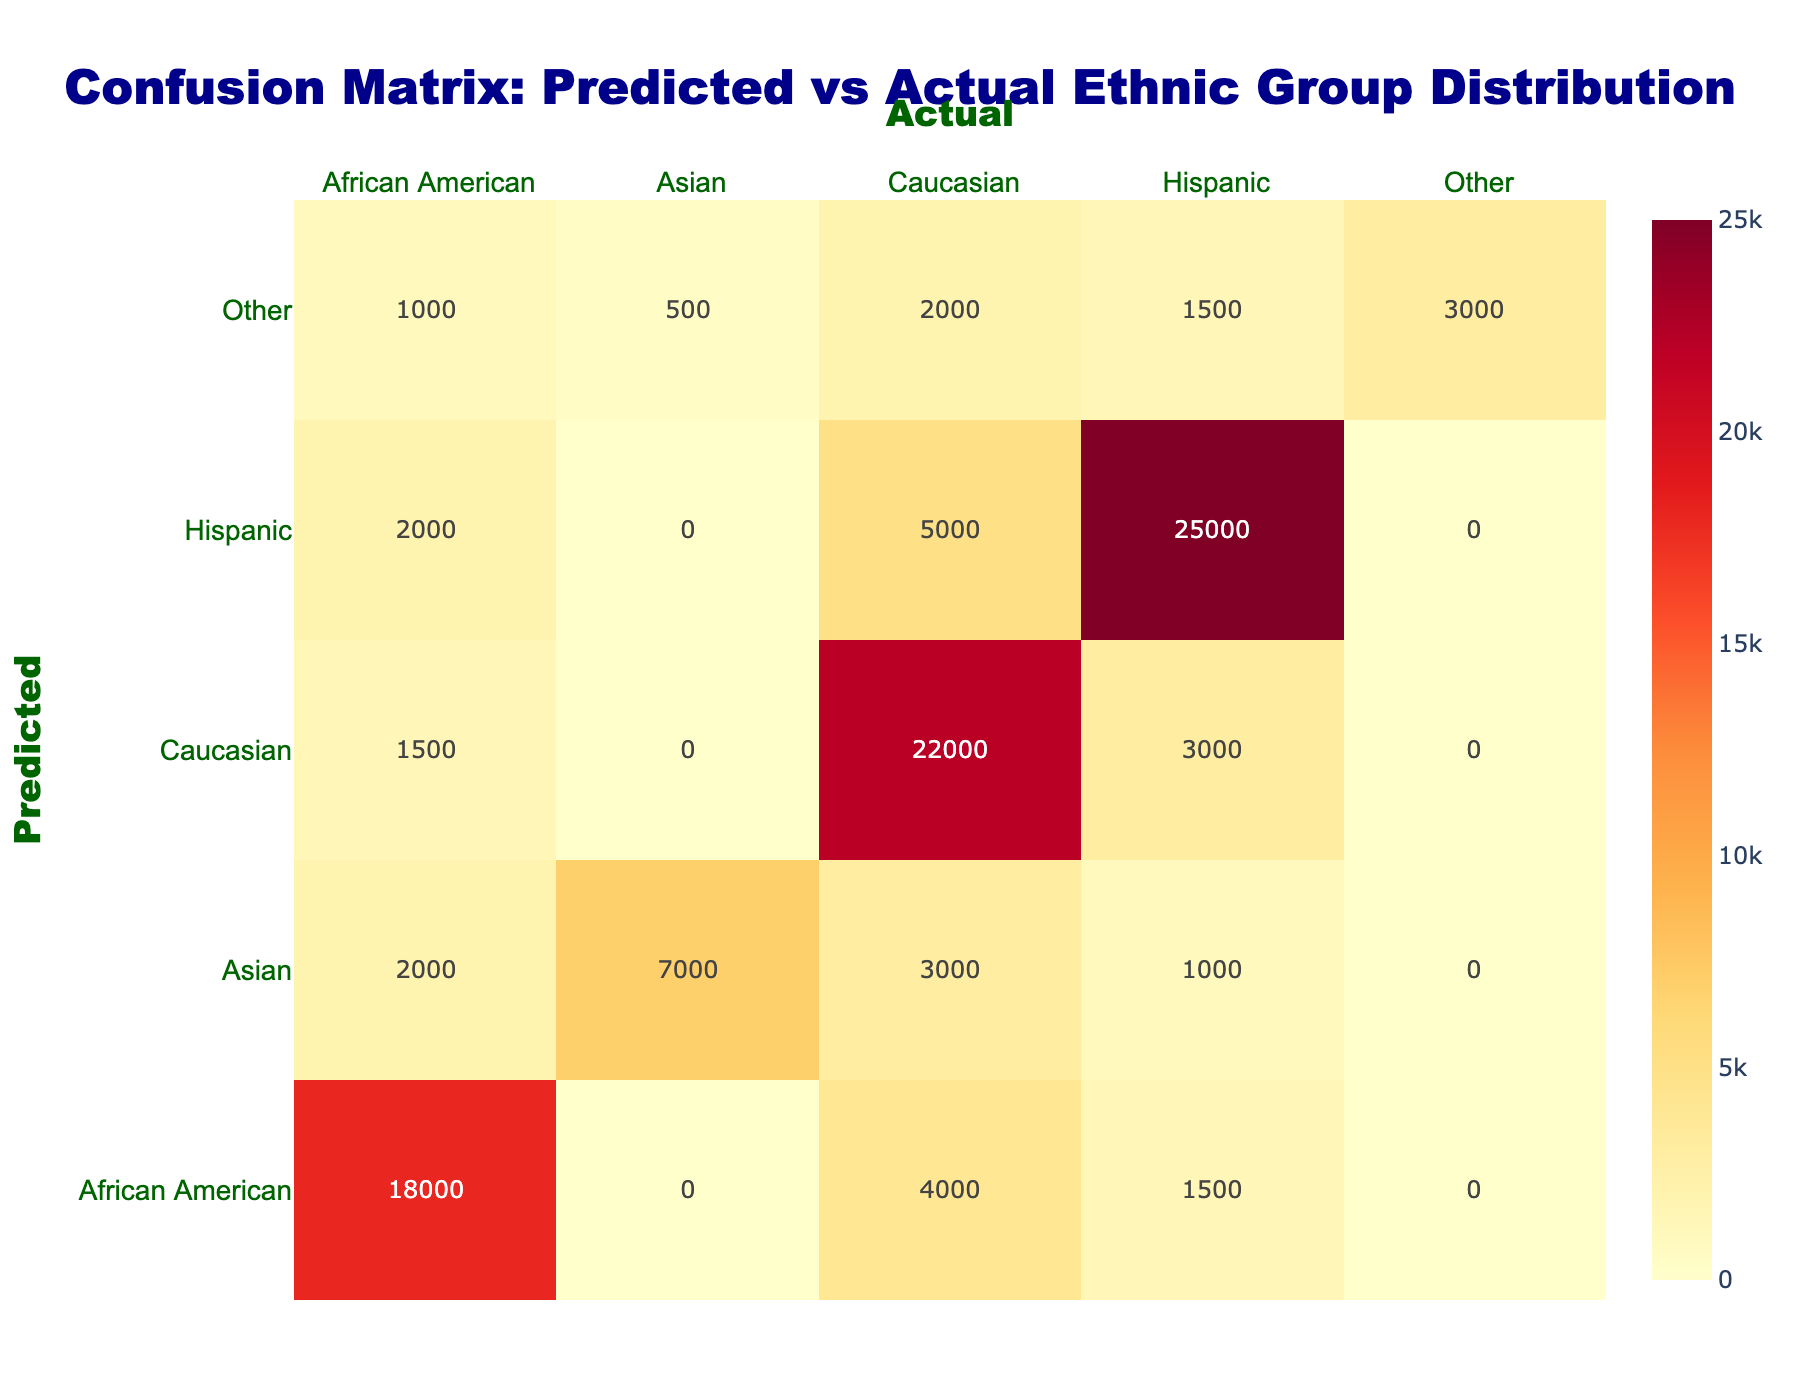What is the predicted population of Hispanic individuals that were actual Caucasian? The table shows that the predicted population of Hispanic individuals that were actual Caucasian is 5000, which is directly stated in the cell corresponding to Predicted Hispanic and Actual Caucasian.
Answer: 5000 What is the total population of actual Hispanic individuals? To find this, sum all predicted values where Actual is Hispanic: (25000 + 3000 + 1500 + 1000 + 1500 = 30000). The total population of actual Hispanic individuals is 30000.
Answer: 30000 Is the predicted population of Asian individuals who are actually Caucasian greater than the predicted population of Hispanic individuals who are actually African American? The predicted population of Asian individuals that are actually Caucasian is 3000, and the predicted population of Hispanic individuals that are actually African American is 2000. Since 3000 is greater than 2000, the answer is yes.
Answer: Yes What percentage of the predicted Hispanic population was correctly predicted? To find this percentage, divide the correctly predicted Hispanic population (25000) by the total predicted Hispanic population (25000 + 5000 + 2000 = 32000), then multiply by 100. So (25000 / 32000) * 100 = 78.125%.
Answer: 78.125% How many actual African American individuals were predicted incorrectly as Caucasian? The table indicates that 4000 individuals who are actually African American were predicted as Caucasian. This is directly stated under Predicted Caucasian and Actual African American.
Answer: 4000 What is the total number of individuals predicted as Asian? To find this, sum all populations where Predicted is Asian across different actual categories: (1000 + 3000 + 2000 + 7000 = 13000). Therefore, the total number predicted as Asian is 13000.
Answer: 13000 Is the predicted population of individuals from the 'Other' category that were actually Hispanic greater than those that were actually Asian? For 'Other' predicted individuals: those who are actually Hispanic total 1500 and those who are actually Asian total 500. Since 1500 is greater than 500, the answer is yes.
Answer: Yes What is the average number of predicted individuals for each ethnic group? To find the average, we first sum the predicted populations for each group: (25000 + 5000 + 2000 + 3000 + 22000 + 1500 + 1500 + 4000 + 18000 + 1000 + 3000 + 2000 + 7000 + 1500 + 2000 + 1000 + 500 + 3000 = 116500). There are 17 predictions in total, therefore the average is 116500 / 17 = 6852.94.
Answer: 6852.94 